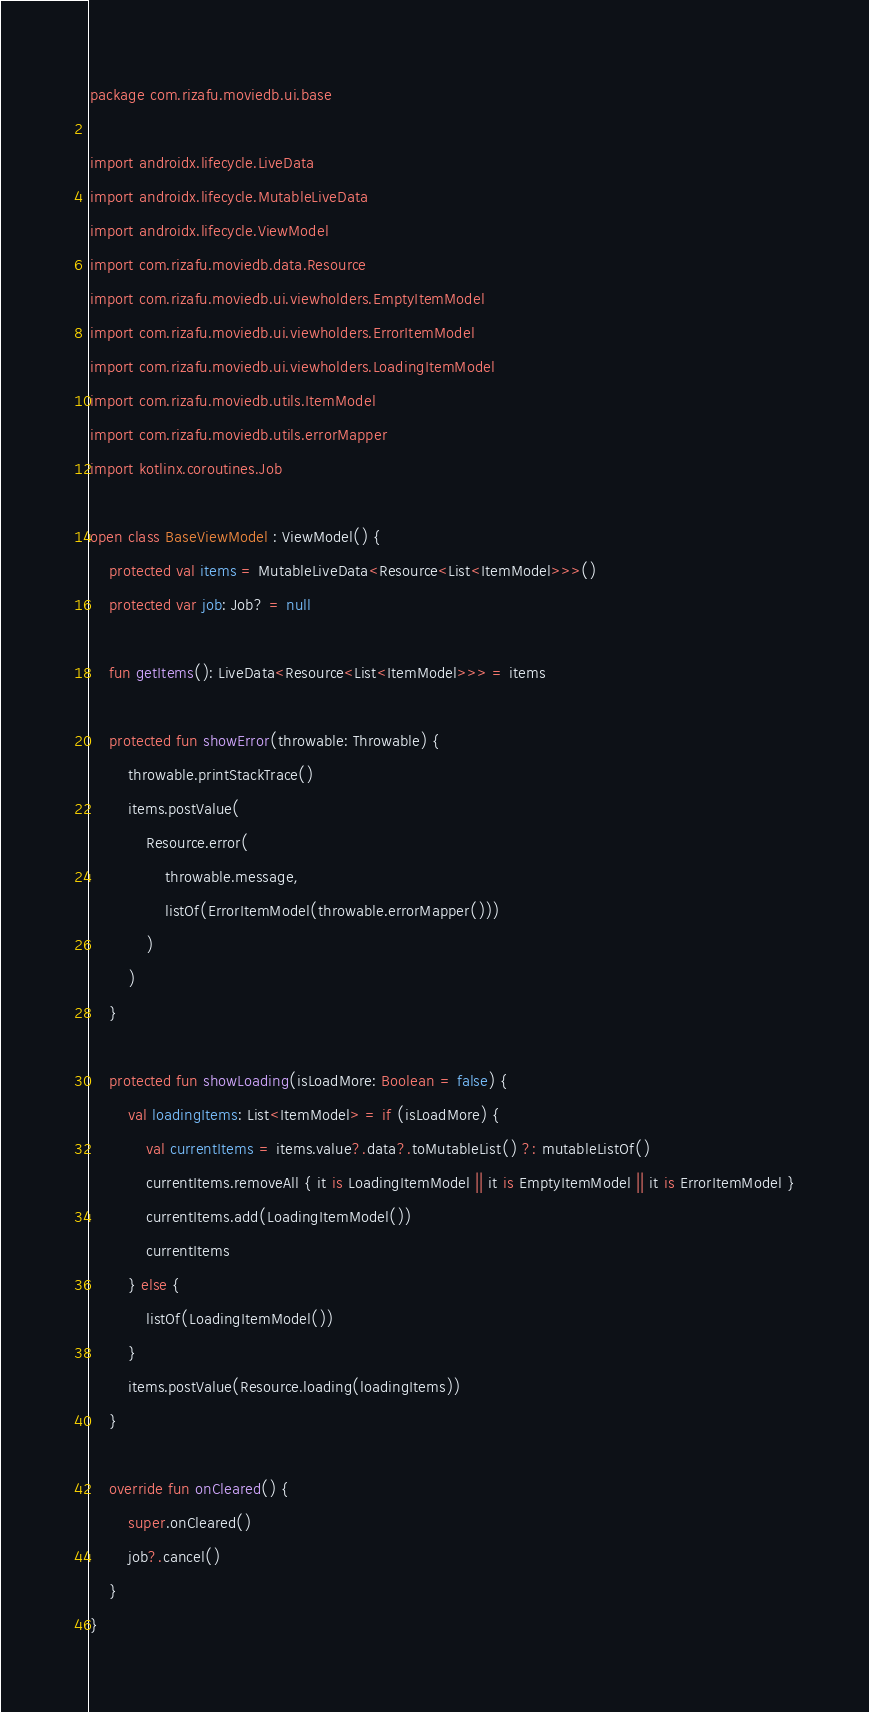<code> <loc_0><loc_0><loc_500><loc_500><_Kotlin_>package com.rizafu.moviedb.ui.base

import androidx.lifecycle.LiveData
import androidx.lifecycle.MutableLiveData
import androidx.lifecycle.ViewModel
import com.rizafu.moviedb.data.Resource
import com.rizafu.moviedb.ui.viewholders.EmptyItemModel
import com.rizafu.moviedb.ui.viewholders.ErrorItemModel
import com.rizafu.moviedb.ui.viewholders.LoadingItemModel
import com.rizafu.moviedb.utils.ItemModel
import com.rizafu.moviedb.utils.errorMapper
import kotlinx.coroutines.Job

open class BaseViewModel : ViewModel() {
    protected val items = MutableLiveData<Resource<List<ItemModel>>>()
    protected var job: Job? = null

    fun getItems(): LiveData<Resource<List<ItemModel>>> = items

    protected fun showError(throwable: Throwable) {
        throwable.printStackTrace()
        items.postValue(
            Resource.error(
                throwable.message,
                listOf(ErrorItemModel(throwable.errorMapper()))
            )
        )
    }

    protected fun showLoading(isLoadMore: Boolean = false) {
        val loadingItems: List<ItemModel> = if (isLoadMore) {
            val currentItems = items.value?.data?.toMutableList() ?: mutableListOf()
            currentItems.removeAll { it is LoadingItemModel || it is EmptyItemModel || it is ErrorItemModel }
            currentItems.add(LoadingItemModel())
            currentItems
        } else {
            listOf(LoadingItemModel())
        }
        items.postValue(Resource.loading(loadingItems))
    }

    override fun onCleared() {
        super.onCleared()
        job?.cancel()
    }
}</code> 